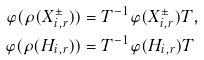<formula> <loc_0><loc_0><loc_500><loc_500>\varphi ( \rho ( X _ { i , r } ^ { \pm } ) ) & = T ^ { - 1 } \varphi ( X _ { i , r } ^ { \pm } ) T , \\ \varphi ( \rho ( H _ { i , r } ) ) & = T ^ { - 1 } \varphi ( H _ { i , r } ) T</formula> 